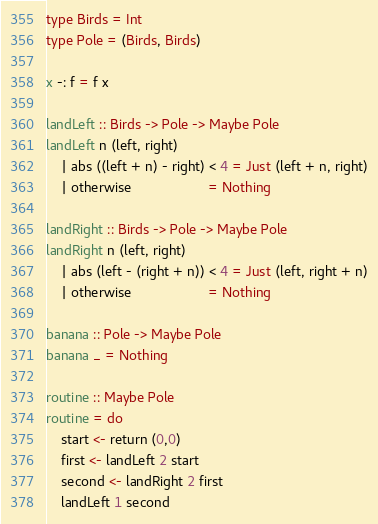<code> <loc_0><loc_0><loc_500><loc_500><_Haskell_>type Birds = Int
type Pole = (Birds, Birds)

x -: f = f x

landLeft :: Birds -> Pole -> Maybe Pole
landLeft n (left, right)
    | abs ((left + n) - right) < 4 = Just (left + n, right)
    | otherwise                    = Nothing

landRight :: Birds -> Pole -> Maybe Pole
landRight n (left, right)
    | abs (left - (right + n)) < 4 = Just (left, right + n)
    | otherwise                    = Nothing

banana :: Pole -> Maybe Pole
banana _ = Nothing

routine :: Maybe Pole
routine = do
    start <- return (0,0)
    first <- landLeft 2 start
    second <- landRight 2 first
    landLeft 1 second
</code> 